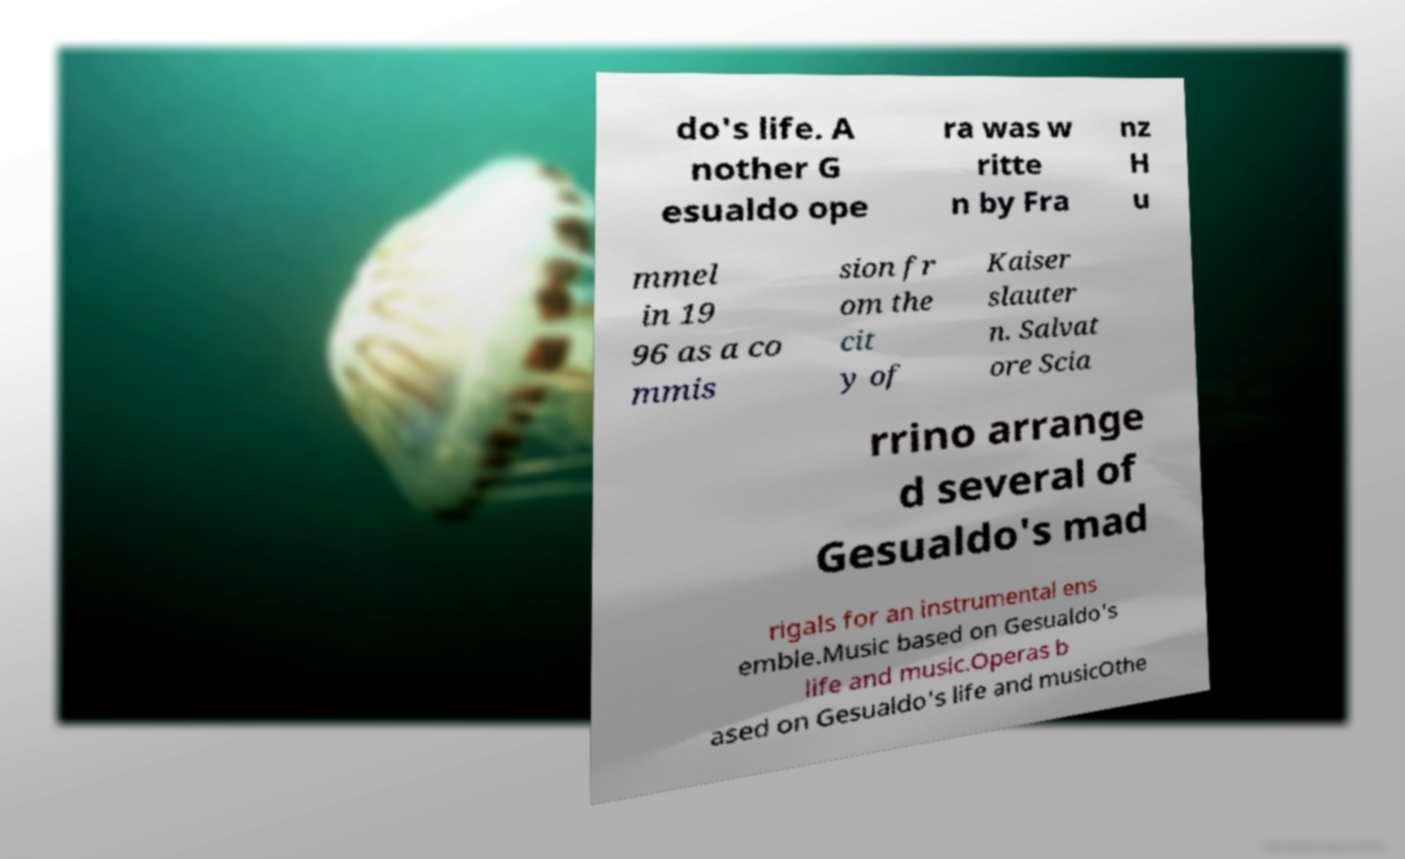Please read and relay the text visible in this image. What does it say? do's life. A nother G esualdo ope ra was w ritte n by Fra nz H u mmel in 19 96 as a co mmis sion fr om the cit y of Kaiser slauter n. Salvat ore Scia rrino arrange d several of Gesualdo's mad rigals for an instrumental ens emble.Music based on Gesualdo's life and music.Operas b ased on Gesualdo's life and musicOthe 